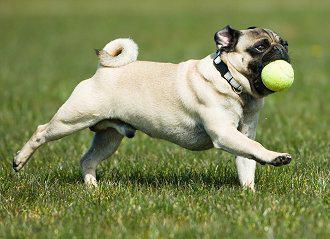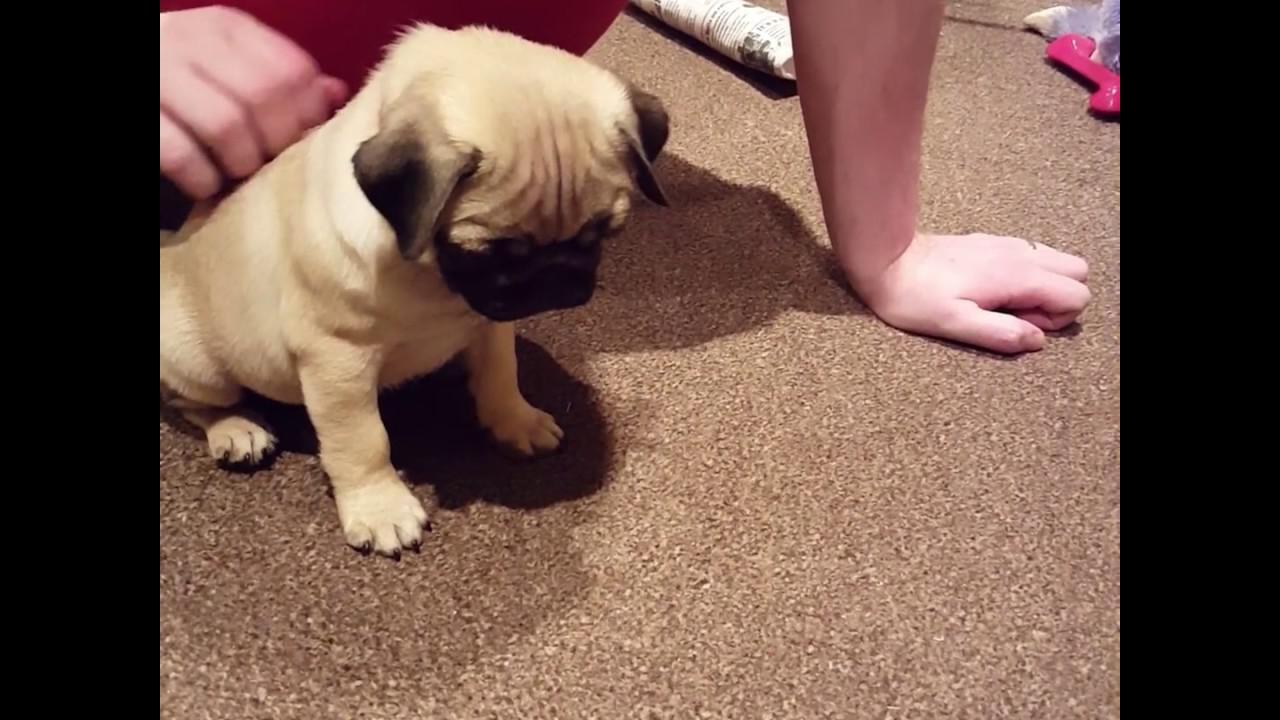The first image is the image on the left, the second image is the image on the right. Analyze the images presented: Is the assertion "A dog in one of the images is sitting in the grass." valid? Answer yes or no. No. The first image is the image on the left, the second image is the image on the right. Given the left and right images, does the statement "All dogs are shown on green grass, and no dog is in an action pose." hold true? Answer yes or no. No. 